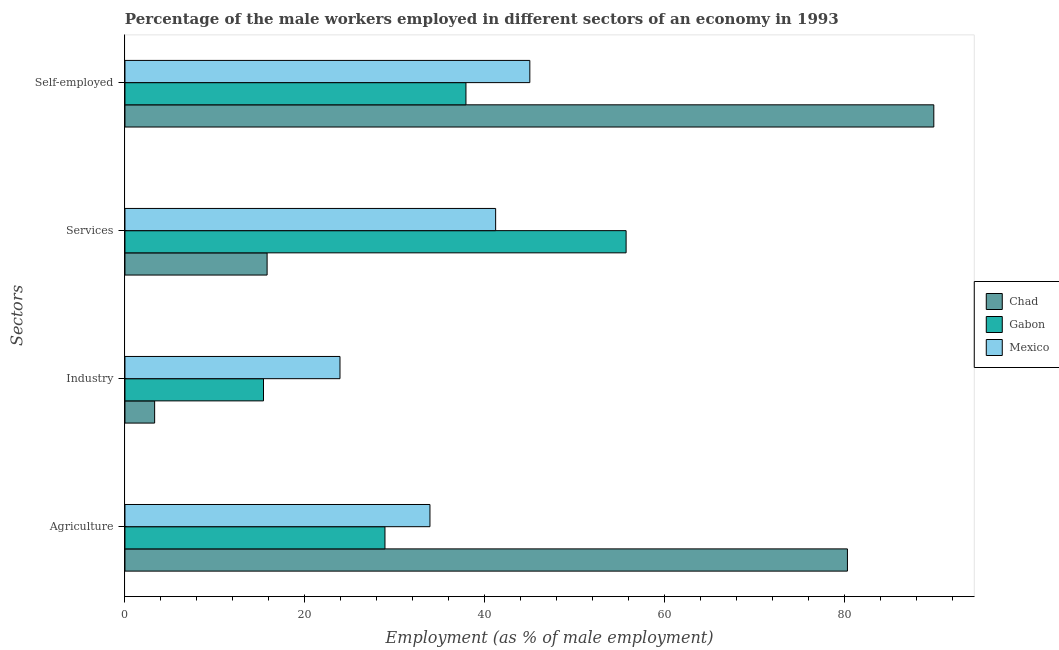Are the number of bars on each tick of the Y-axis equal?
Provide a succinct answer. Yes. How many bars are there on the 3rd tick from the top?
Provide a succinct answer. 3. What is the label of the 2nd group of bars from the top?
Give a very brief answer. Services. What is the percentage of self employed male workers in Gabon?
Give a very brief answer. 37.9. Across all countries, what is the maximum percentage of self employed male workers?
Offer a very short reply. 89.9. Across all countries, what is the minimum percentage of self employed male workers?
Make the answer very short. 37.9. In which country was the percentage of self employed male workers maximum?
Provide a succinct answer. Chad. In which country was the percentage of male workers in industry minimum?
Ensure brevity in your answer.  Chad. What is the total percentage of male workers in services in the graph?
Provide a succinct answer. 112.7. What is the difference between the percentage of male workers in industry in Chad and that in Mexico?
Provide a succinct answer. -20.6. What is the difference between the percentage of male workers in services in Gabon and the percentage of male workers in industry in Chad?
Your response must be concise. 52.4. What is the average percentage of self employed male workers per country?
Offer a terse response. 57.6. What is the difference between the percentage of male workers in services and percentage of self employed male workers in Chad?
Provide a short and direct response. -74.1. What is the ratio of the percentage of self employed male workers in Chad to that in Mexico?
Offer a very short reply. 2. Is the percentage of male workers in industry in Mexico less than that in Chad?
Give a very brief answer. No. What is the difference between the highest and the second highest percentage of male workers in industry?
Your answer should be very brief. 8.5. What is the difference between the highest and the lowest percentage of male workers in agriculture?
Give a very brief answer. 51.4. Is the sum of the percentage of male workers in services in Mexico and Gabon greater than the maximum percentage of male workers in industry across all countries?
Provide a succinct answer. Yes. Is it the case that in every country, the sum of the percentage of male workers in agriculture and percentage of self employed male workers is greater than the sum of percentage of male workers in services and percentage of male workers in industry?
Keep it short and to the point. No. What does the 3rd bar from the top in Services represents?
Offer a terse response. Chad. What does the 1st bar from the bottom in Services represents?
Your answer should be very brief. Chad. How many bars are there?
Offer a terse response. 12. Are the values on the major ticks of X-axis written in scientific E-notation?
Your response must be concise. No. What is the title of the graph?
Your response must be concise. Percentage of the male workers employed in different sectors of an economy in 1993. Does "Cote d'Ivoire" appear as one of the legend labels in the graph?
Your answer should be compact. No. What is the label or title of the X-axis?
Make the answer very short. Employment (as % of male employment). What is the label or title of the Y-axis?
Your response must be concise. Sectors. What is the Employment (as % of male employment) in Chad in Agriculture?
Your answer should be compact. 80.3. What is the Employment (as % of male employment) in Gabon in Agriculture?
Make the answer very short. 28.9. What is the Employment (as % of male employment) in Mexico in Agriculture?
Offer a terse response. 33.9. What is the Employment (as % of male employment) of Chad in Industry?
Keep it short and to the point. 3.3. What is the Employment (as % of male employment) of Gabon in Industry?
Provide a succinct answer. 15.4. What is the Employment (as % of male employment) of Mexico in Industry?
Your answer should be very brief. 23.9. What is the Employment (as % of male employment) in Chad in Services?
Your response must be concise. 15.8. What is the Employment (as % of male employment) of Gabon in Services?
Your response must be concise. 55.7. What is the Employment (as % of male employment) of Mexico in Services?
Offer a very short reply. 41.2. What is the Employment (as % of male employment) in Chad in Self-employed?
Your answer should be very brief. 89.9. What is the Employment (as % of male employment) in Gabon in Self-employed?
Your answer should be very brief. 37.9. Across all Sectors, what is the maximum Employment (as % of male employment) of Chad?
Offer a very short reply. 89.9. Across all Sectors, what is the maximum Employment (as % of male employment) of Gabon?
Provide a succinct answer. 55.7. Across all Sectors, what is the minimum Employment (as % of male employment) of Chad?
Give a very brief answer. 3.3. Across all Sectors, what is the minimum Employment (as % of male employment) in Gabon?
Keep it short and to the point. 15.4. Across all Sectors, what is the minimum Employment (as % of male employment) in Mexico?
Give a very brief answer. 23.9. What is the total Employment (as % of male employment) of Chad in the graph?
Offer a terse response. 189.3. What is the total Employment (as % of male employment) of Gabon in the graph?
Ensure brevity in your answer.  137.9. What is the total Employment (as % of male employment) in Mexico in the graph?
Keep it short and to the point. 144. What is the difference between the Employment (as % of male employment) in Gabon in Agriculture and that in Industry?
Provide a succinct answer. 13.5. What is the difference between the Employment (as % of male employment) of Chad in Agriculture and that in Services?
Your answer should be compact. 64.5. What is the difference between the Employment (as % of male employment) in Gabon in Agriculture and that in Services?
Give a very brief answer. -26.8. What is the difference between the Employment (as % of male employment) of Chad in Agriculture and that in Self-employed?
Provide a short and direct response. -9.6. What is the difference between the Employment (as % of male employment) of Gabon in Agriculture and that in Self-employed?
Offer a very short reply. -9. What is the difference between the Employment (as % of male employment) of Gabon in Industry and that in Services?
Your answer should be compact. -40.3. What is the difference between the Employment (as % of male employment) of Mexico in Industry and that in Services?
Keep it short and to the point. -17.3. What is the difference between the Employment (as % of male employment) in Chad in Industry and that in Self-employed?
Your response must be concise. -86.6. What is the difference between the Employment (as % of male employment) in Gabon in Industry and that in Self-employed?
Offer a terse response. -22.5. What is the difference between the Employment (as % of male employment) of Mexico in Industry and that in Self-employed?
Keep it short and to the point. -21.1. What is the difference between the Employment (as % of male employment) in Chad in Services and that in Self-employed?
Ensure brevity in your answer.  -74.1. What is the difference between the Employment (as % of male employment) in Mexico in Services and that in Self-employed?
Your response must be concise. -3.8. What is the difference between the Employment (as % of male employment) of Chad in Agriculture and the Employment (as % of male employment) of Gabon in Industry?
Offer a very short reply. 64.9. What is the difference between the Employment (as % of male employment) in Chad in Agriculture and the Employment (as % of male employment) in Mexico in Industry?
Ensure brevity in your answer.  56.4. What is the difference between the Employment (as % of male employment) of Chad in Agriculture and the Employment (as % of male employment) of Gabon in Services?
Offer a terse response. 24.6. What is the difference between the Employment (as % of male employment) of Chad in Agriculture and the Employment (as % of male employment) of Mexico in Services?
Your answer should be very brief. 39.1. What is the difference between the Employment (as % of male employment) in Chad in Agriculture and the Employment (as % of male employment) in Gabon in Self-employed?
Give a very brief answer. 42.4. What is the difference between the Employment (as % of male employment) of Chad in Agriculture and the Employment (as % of male employment) of Mexico in Self-employed?
Offer a very short reply. 35.3. What is the difference between the Employment (as % of male employment) of Gabon in Agriculture and the Employment (as % of male employment) of Mexico in Self-employed?
Give a very brief answer. -16.1. What is the difference between the Employment (as % of male employment) in Chad in Industry and the Employment (as % of male employment) in Gabon in Services?
Give a very brief answer. -52.4. What is the difference between the Employment (as % of male employment) in Chad in Industry and the Employment (as % of male employment) in Mexico in Services?
Offer a very short reply. -37.9. What is the difference between the Employment (as % of male employment) of Gabon in Industry and the Employment (as % of male employment) of Mexico in Services?
Ensure brevity in your answer.  -25.8. What is the difference between the Employment (as % of male employment) in Chad in Industry and the Employment (as % of male employment) in Gabon in Self-employed?
Your answer should be compact. -34.6. What is the difference between the Employment (as % of male employment) in Chad in Industry and the Employment (as % of male employment) in Mexico in Self-employed?
Your answer should be compact. -41.7. What is the difference between the Employment (as % of male employment) in Gabon in Industry and the Employment (as % of male employment) in Mexico in Self-employed?
Keep it short and to the point. -29.6. What is the difference between the Employment (as % of male employment) of Chad in Services and the Employment (as % of male employment) of Gabon in Self-employed?
Provide a succinct answer. -22.1. What is the difference between the Employment (as % of male employment) of Chad in Services and the Employment (as % of male employment) of Mexico in Self-employed?
Give a very brief answer. -29.2. What is the difference between the Employment (as % of male employment) in Gabon in Services and the Employment (as % of male employment) in Mexico in Self-employed?
Your answer should be very brief. 10.7. What is the average Employment (as % of male employment) of Chad per Sectors?
Offer a very short reply. 47.33. What is the average Employment (as % of male employment) of Gabon per Sectors?
Keep it short and to the point. 34.48. What is the difference between the Employment (as % of male employment) in Chad and Employment (as % of male employment) in Gabon in Agriculture?
Your answer should be compact. 51.4. What is the difference between the Employment (as % of male employment) of Chad and Employment (as % of male employment) of Mexico in Agriculture?
Provide a succinct answer. 46.4. What is the difference between the Employment (as % of male employment) of Gabon and Employment (as % of male employment) of Mexico in Agriculture?
Keep it short and to the point. -5. What is the difference between the Employment (as % of male employment) in Chad and Employment (as % of male employment) in Gabon in Industry?
Your answer should be very brief. -12.1. What is the difference between the Employment (as % of male employment) in Chad and Employment (as % of male employment) in Mexico in Industry?
Your answer should be very brief. -20.6. What is the difference between the Employment (as % of male employment) of Chad and Employment (as % of male employment) of Gabon in Services?
Make the answer very short. -39.9. What is the difference between the Employment (as % of male employment) in Chad and Employment (as % of male employment) in Mexico in Services?
Your answer should be compact. -25.4. What is the difference between the Employment (as % of male employment) of Chad and Employment (as % of male employment) of Gabon in Self-employed?
Keep it short and to the point. 52. What is the difference between the Employment (as % of male employment) of Chad and Employment (as % of male employment) of Mexico in Self-employed?
Offer a terse response. 44.9. What is the ratio of the Employment (as % of male employment) of Chad in Agriculture to that in Industry?
Your response must be concise. 24.33. What is the ratio of the Employment (as % of male employment) in Gabon in Agriculture to that in Industry?
Keep it short and to the point. 1.88. What is the ratio of the Employment (as % of male employment) of Mexico in Agriculture to that in Industry?
Your response must be concise. 1.42. What is the ratio of the Employment (as % of male employment) in Chad in Agriculture to that in Services?
Your response must be concise. 5.08. What is the ratio of the Employment (as % of male employment) of Gabon in Agriculture to that in Services?
Provide a succinct answer. 0.52. What is the ratio of the Employment (as % of male employment) in Mexico in Agriculture to that in Services?
Your response must be concise. 0.82. What is the ratio of the Employment (as % of male employment) of Chad in Agriculture to that in Self-employed?
Your response must be concise. 0.89. What is the ratio of the Employment (as % of male employment) in Gabon in Agriculture to that in Self-employed?
Provide a short and direct response. 0.76. What is the ratio of the Employment (as % of male employment) in Mexico in Agriculture to that in Self-employed?
Offer a very short reply. 0.75. What is the ratio of the Employment (as % of male employment) of Chad in Industry to that in Services?
Offer a terse response. 0.21. What is the ratio of the Employment (as % of male employment) of Gabon in Industry to that in Services?
Give a very brief answer. 0.28. What is the ratio of the Employment (as % of male employment) in Mexico in Industry to that in Services?
Offer a terse response. 0.58. What is the ratio of the Employment (as % of male employment) of Chad in Industry to that in Self-employed?
Your answer should be compact. 0.04. What is the ratio of the Employment (as % of male employment) of Gabon in Industry to that in Self-employed?
Provide a short and direct response. 0.41. What is the ratio of the Employment (as % of male employment) of Mexico in Industry to that in Self-employed?
Your answer should be compact. 0.53. What is the ratio of the Employment (as % of male employment) of Chad in Services to that in Self-employed?
Your answer should be compact. 0.18. What is the ratio of the Employment (as % of male employment) of Gabon in Services to that in Self-employed?
Provide a succinct answer. 1.47. What is the ratio of the Employment (as % of male employment) of Mexico in Services to that in Self-employed?
Your answer should be compact. 0.92. What is the difference between the highest and the second highest Employment (as % of male employment) in Gabon?
Provide a short and direct response. 17.8. What is the difference between the highest and the second highest Employment (as % of male employment) in Mexico?
Keep it short and to the point. 3.8. What is the difference between the highest and the lowest Employment (as % of male employment) in Chad?
Offer a terse response. 86.6. What is the difference between the highest and the lowest Employment (as % of male employment) of Gabon?
Keep it short and to the point. 40.3. What is the difference between the highest and the lowest Employment (as % of male employment) in Mexico?
Offer a very short reply. 21.1. 